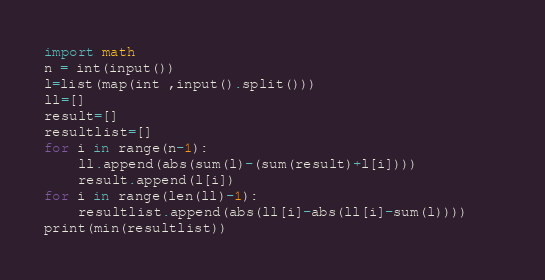Convert code to text. <code><loc_0><loc_0><loc_500><loc_500><_Python_>import math
n = int(input())
l=list(map(int ,input().split()))
ll=[]
result=[]
resultlist=[]
for i in range(n-1):
    ll.append(abs(sum(l)-(sum(result)+l[i])))
    result.append(l[i])
for i in range(len(ll)-1):
    resultlist.append(abs(ll[i]-abs(ll[i]-sum(l))))    
print(min(resultlist))</code> 